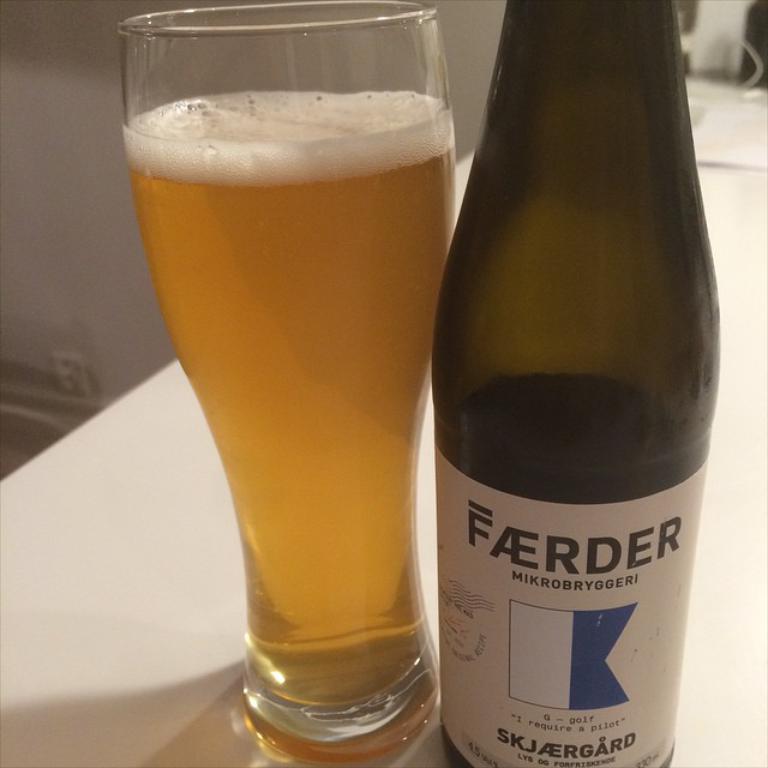Can you describe this image briefly? In this picture there is a table, on the table there is a glass and a bottle. Glass is filled with the liquid. 